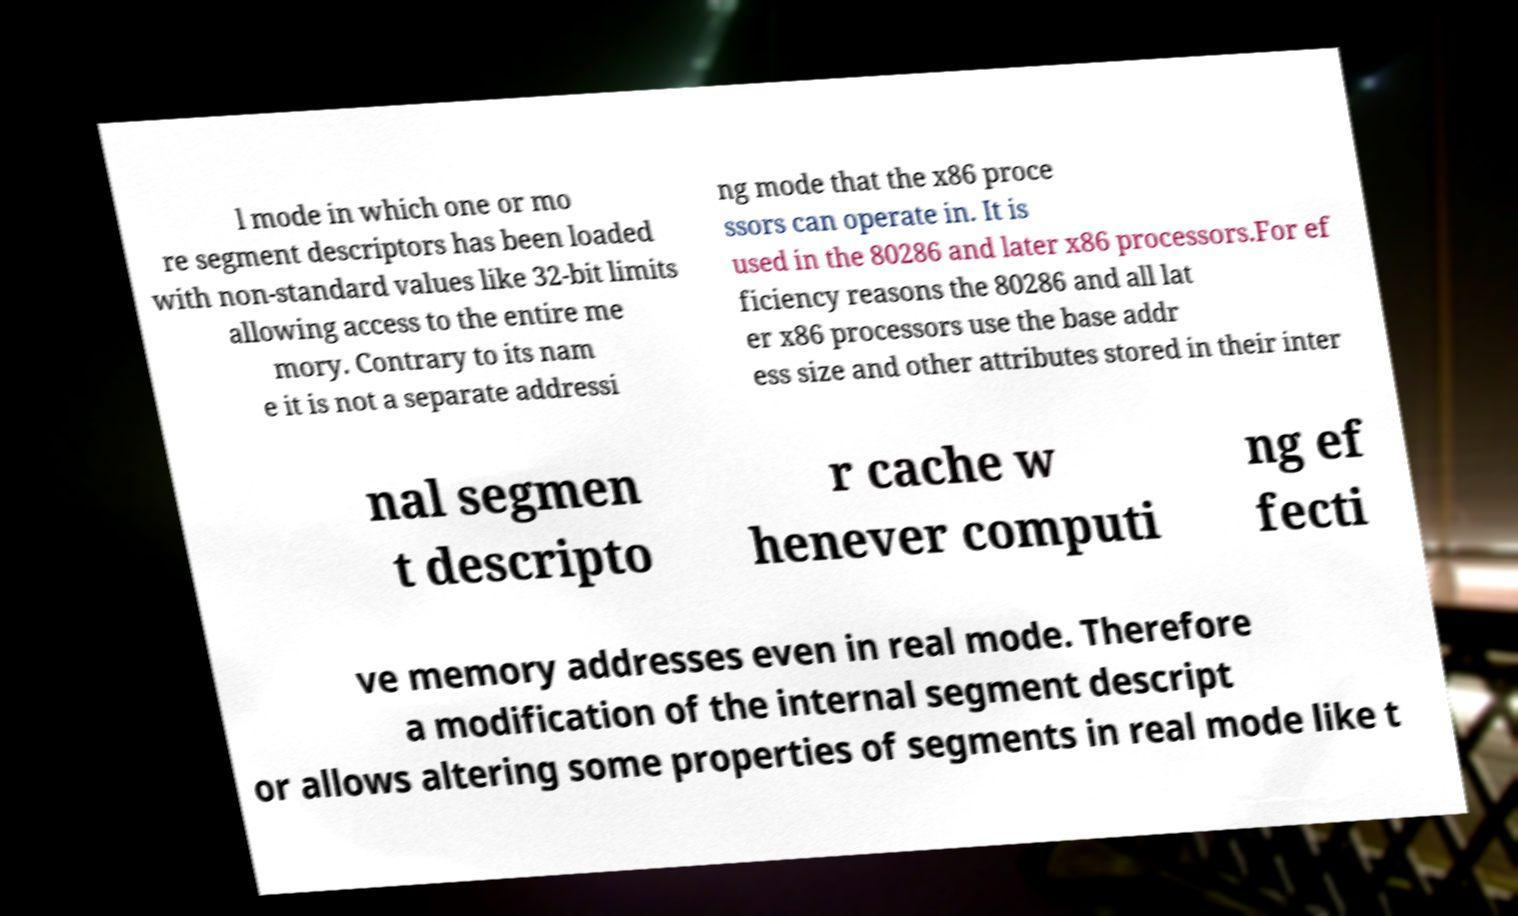Could you assist in decoding the text presented in this image and type it out clearly? l mode in which one or mo re segment descriptors has been loaded with non-standard values like 32-bit limits allowing access to the entire me mory. Contrary to its nam e it is not a separate addressi ng mode that the x86 proce ssors can operate in. It is used in the 80286 and later x86 processors.For ef ficiency reasons the 80286 and all lat er x86 processors use the base addr ess size and other attributes stored in their inter nal segmen t descripto r cache w henever computi ng ef fecti ve memory addresses even in real mode. Therefore a modification of the internal segment descript or allows altering some properties of segments in real mode like t 